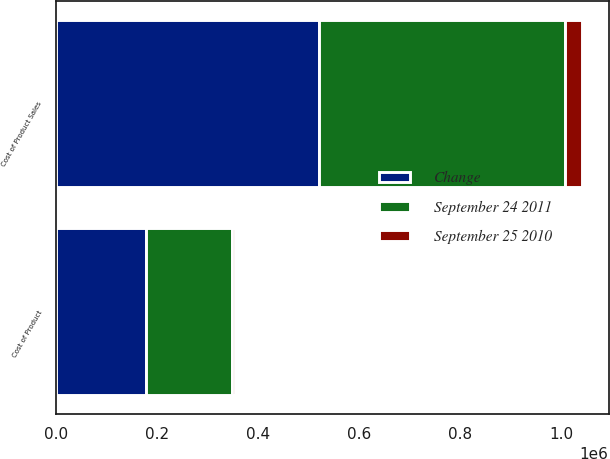<chart> <loc_0><loc_0><loc_500><loc_500><stacked_bar_chart><ecel><fcel>Cost of Product Sales<fcel>Cost of Product<nl><fcel>Change<fcel>521189<fcel>177456<nl><fcel>September 24 2011<fcel>487057<fcel>171447<nl><fcel>September 25 2010<fcel>34132<fcel>6009<nl></chart> 